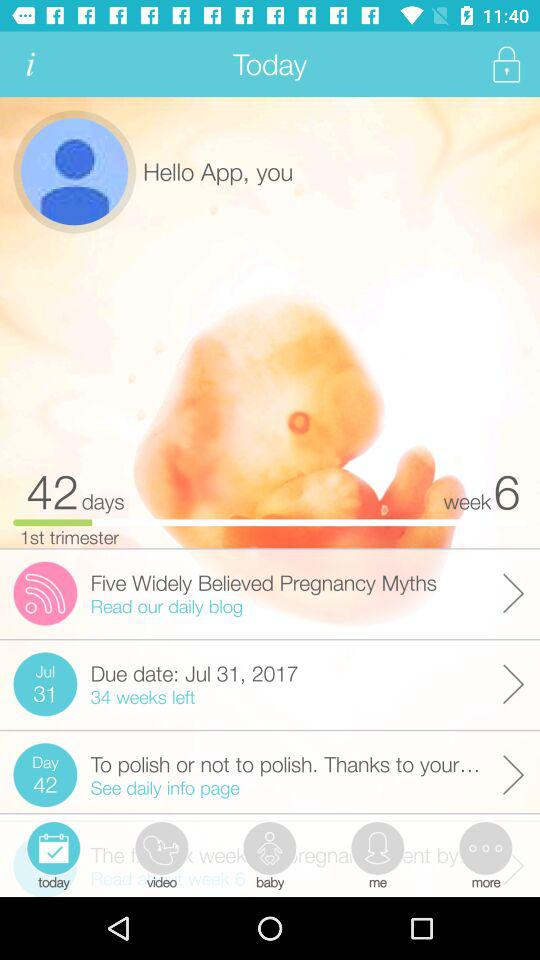Which trimester is currently ongoing? The currently ongoing trimester is the first. 